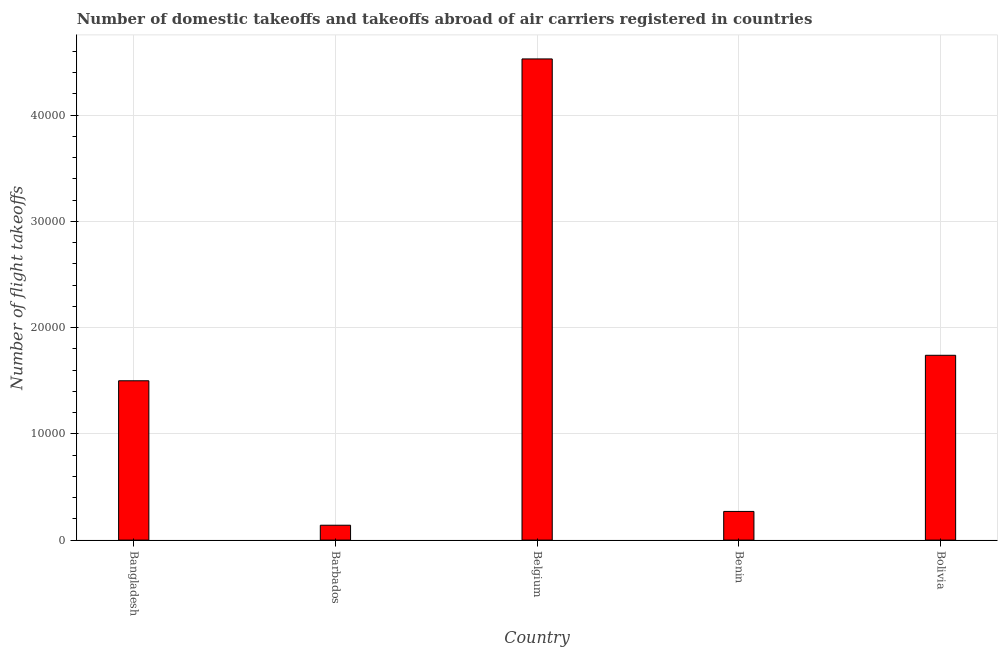Does the graph contain any zero values?
Your answer should be very brief. No. What is the title of the graph?
Ensure brevity in your answer.  Number of domestic takeoffs and takeoffs abroad of air carriers registered in countries. What is the label or title of the X-axis?
Your answer should be very brief. Country. What is the label or title of the Y-axis?
Provide a short and direct response. Number of flight takeoffs. What is the number of flight takeoffs in Bolivia?
Provide a succinct answer. 1.74e+04. Across all countries, what is the maximum number of flight takeoffs?
Give a very brief answer. 4.53e+04. Across all countries, what is the minimum number of flight takeoffs?
Offer a very short reply. 1400. In which country was the number of flight takeoffs maximum?
Offer a terse response. Belgium. In which country was the number of flight takeoffs minimum?
Offer a terse response. Barbados. What is the sum of the number of flight takeoffs?
Keep it short and to the point. 8.18e+04. What is the difference between the number of flight takeoffs in Bangladesh and Bolivia?
Keep it short and to the point. -2400. What is the average number of flight takeoffs per country?
Offer a terse response. 1.64e+04. What is the median number of flight takeoffs?
Your answer should be very brief. 1.50e+04. What is the ratio of the number of flight takeoffs in Benin to that in Bolivia?
Your answer should be compact. 0.15. Is the number of flight takeoffs in Barbados less than that in Benin?
Provide a succinct answer. Yes. Is the difference between the number of flight takeoffs in Bangladesh and Belgium greater than the difference between any two countries?
Offer a terse response. No. What is the difference between the highest and the second highest number of flight takeoffs?
Your answer should be compact. 2.79e+04. Is the sum of the number of flight takeoffs in Barbados and Belgium greater than the maximum number of flight takeoffs across all countries?
Offer a very short reply. Yes. What is the difference between the highest and the lowest number of flight takeoffs?
Ensure brevity in your answer.  4.39e+04. How many bars are there?
Provide a short and direct response. 5. How many countries are there in the graph?
Offer a terse response. 5. What is the Number of flight takeoffs of Bangladesh?
Provide a succinct answer. 1.50e+04. What is the Number of flight takeoffs in Barbados?
Provide a short and direct response. 1400. What is the Number of flight takeoffs in Belgium?
Your answer should be compact. 4.53e+04. What is the Number of flight takeoffs of Benin?
Keep it short and to the point. 2700. What is the Number of flight takeoffs in Bolivia?
Make the answer very short. 1.74e+04. What is the difference between the Number of flight takeoffs in Bangladesh and Barbados?
Your response must be concise. 1.36e+04. What is the difference between the Number of flight takeoffs in Bangladesh and Belgium?
Give a very brief answer. -3.03e+04. What is the difference between the Number of flight takeoffs in Bangladesh and Benin?
Provide a succinct answer. 1.23e+04. What is the difference between the Number of flight takeoffs in Bangladesh and Bolivia?
Provide a short and direct response. -2400. What is the difference between the Number of flight takeoffs in Barbados and Belgium?
Provide a succinct answer. -4.39e+04. What is the difference between the Number of flight takeoffs in Barbados and Benin?
Offer a very short reply. -1300. What is the difference between the Number of flight takeoffs in Barbados and Bolivia?
Offer a terse response. -1.60e+04. What is the difference between the Number of flight takeoffs in Belgium and Benin?
Keep it short and to the point. 4.26e+04. What is the difference between the Number of flight takeoffs in Belgium and Bolivia?
Provide a short and direct response. 2.79e+04. What is the difference between the Number of flight takeoffs in Benin and Bolivia?
Your answer should be compact. -1.47e+04. What is the ratio of the Number of flight takeoffs in Bangladesh to that in Barbados?
Provide a succinct answer. 10.71. What is the ratio of the Number of flight takeoffs in Bangladesh to that in Belgium?
Your answer should be compact. 0.33. What is the ratio of the Number of flight takeoffs in Bangladesh to that in Benin?
Your answer should be very brief. 5.56. What is the ratio of the Number of flight takeoffs in Bangladesh to that in Bolivia?
Ensure brevity in your answer.  0.86. What is the ratio of the Number of flight takeoffs in Barbados to that in Belgium?
Offer a terse response. 0.03. What is the ratio of the Number of flight takeoffs in Barbados to that in Benin?
Your answer should be very brief. 0.52. What is the ratio of the Number of flight takeoffs in Barbados to that in Bolivia?
Offer a terse response. 0.08. What is the ratio of the Number of flight takeoffs in Belgium to that in Benin?
Give a very brief answer. 16.78. What is the ratio of the Number of flight takeoffs in Belgium to that in Bolivia?
Your answer should be very brief. 2.6. What is the ratio of the Number of flight takeoffs in Benin to that in Bolivia?
Your answer should be very brief. 0.15. 